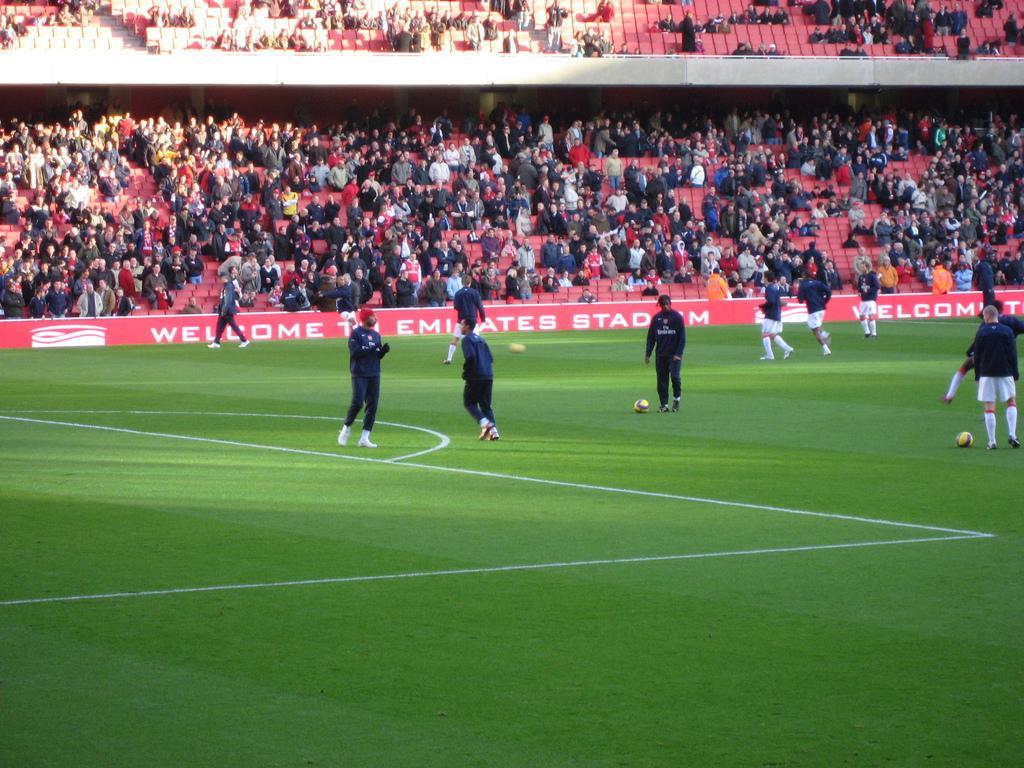Could you give a brief overview of what you see in this image? In this image we can see players are playing on the ground. In the background, we can see so many people are sitting, standing and watching the game. 